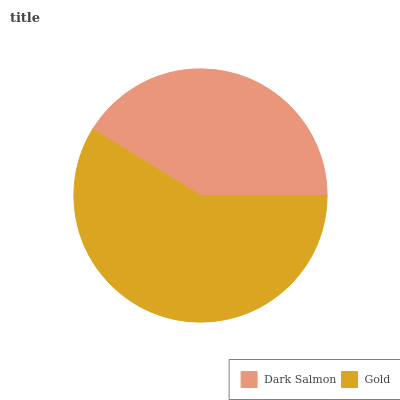Is Dark Salmon the minimum?
Answer yes or no. Yes. Is Gold the maximum?
Answer yes or no. Yes. Is Gold the minimum?
Answer yes or no. No. Is Gold greater than Dark Salmon?
Answer yes or no. Yes. Is Dark Salmon less than Gold?
Answer yes or no. Yes. Is Dark Salmon greater than Gold?
Answer yes or no. No. Is Gold less than Dark Salmon?
Answer yes or no. No. Is Gold the high median?
Answer yes or no. Yes. Is Dark Salmon the low median?
Answer yes or no. Yes. Is Dark Salmon the high median?
Answer yes or no. No. Is Gold the low median?
Answer yes or no. No. 